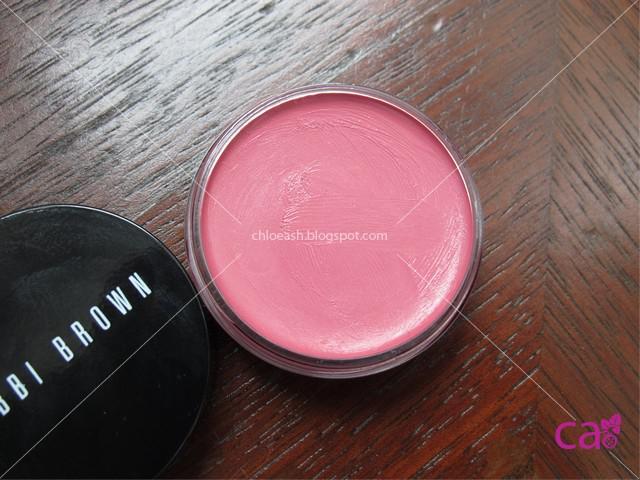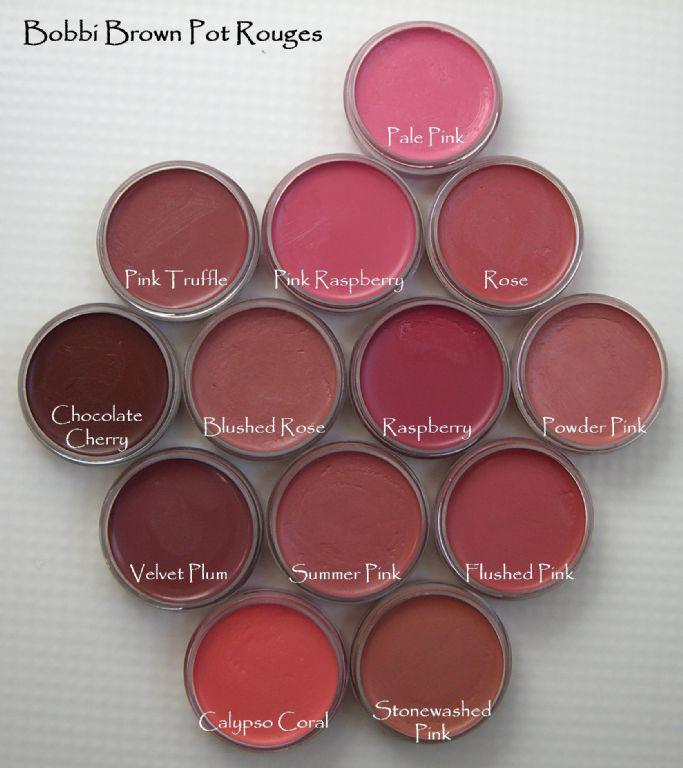The first image is the image on the left, the second image is the image on the right. For the images shown, is this caption "One image shows one opened pot of pink rouge sitting on a wood-look surface." true? Answer yes or no. Yes. The first image is the image on the left, the second image is the image on the right. Analyze the images presented: Is the assertion "In one of the images the makeup is sitting upon a wooden surface." valid? Answer yes or no. Yes. 